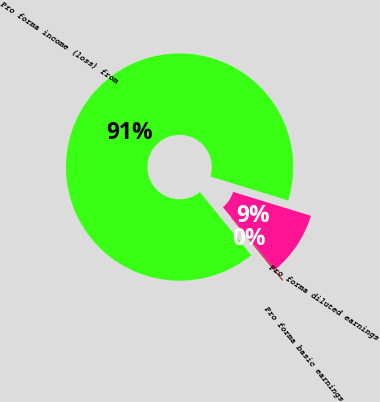<chart> <loc_0><loc_0><loc_500><loc_500><pie_chart><fcel>Pro forma income (loss) from<fcel>Pro forma basic earnings<fcel>Pro forma diluted earnings<nl><fcel>90.61%<fcel>0.17%<fcel>9.22%<nl></chart> 